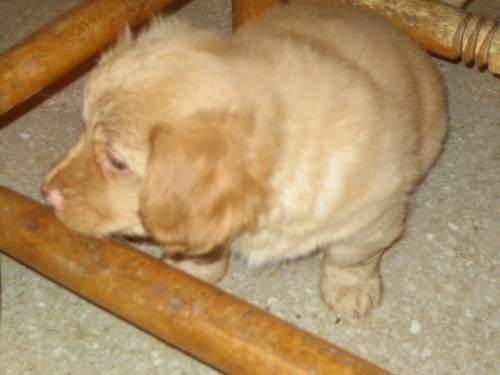What can you say about the texture details in the image? A. Blurry B. Detailed C. Clear D. Sharp Answer with the option's letter from the given choices directly. The texture details in the image most closely align with option C, Clear. Although the image is not of high resolution or sharpness that would classify it as detailed or sharp, the features of the subject, a puppy, are distinguishable without significant blur, suggesting a reasonable level of clarity in the context presented. 